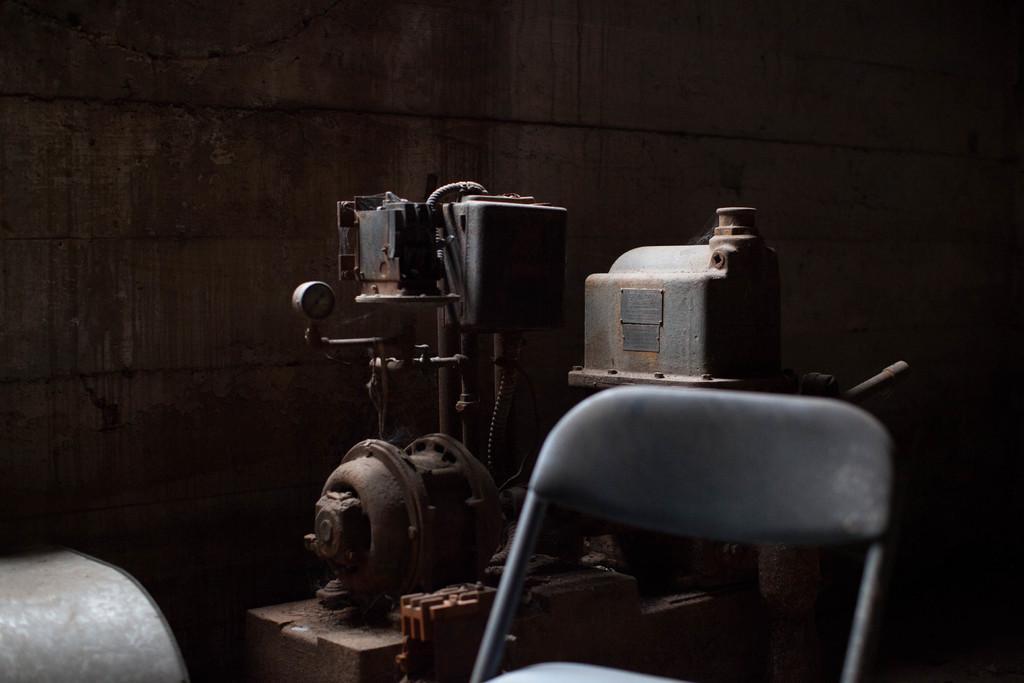Please provide a concise description of this image. In this image we can see the machine. We can also see the chair. In the background there is wall. 